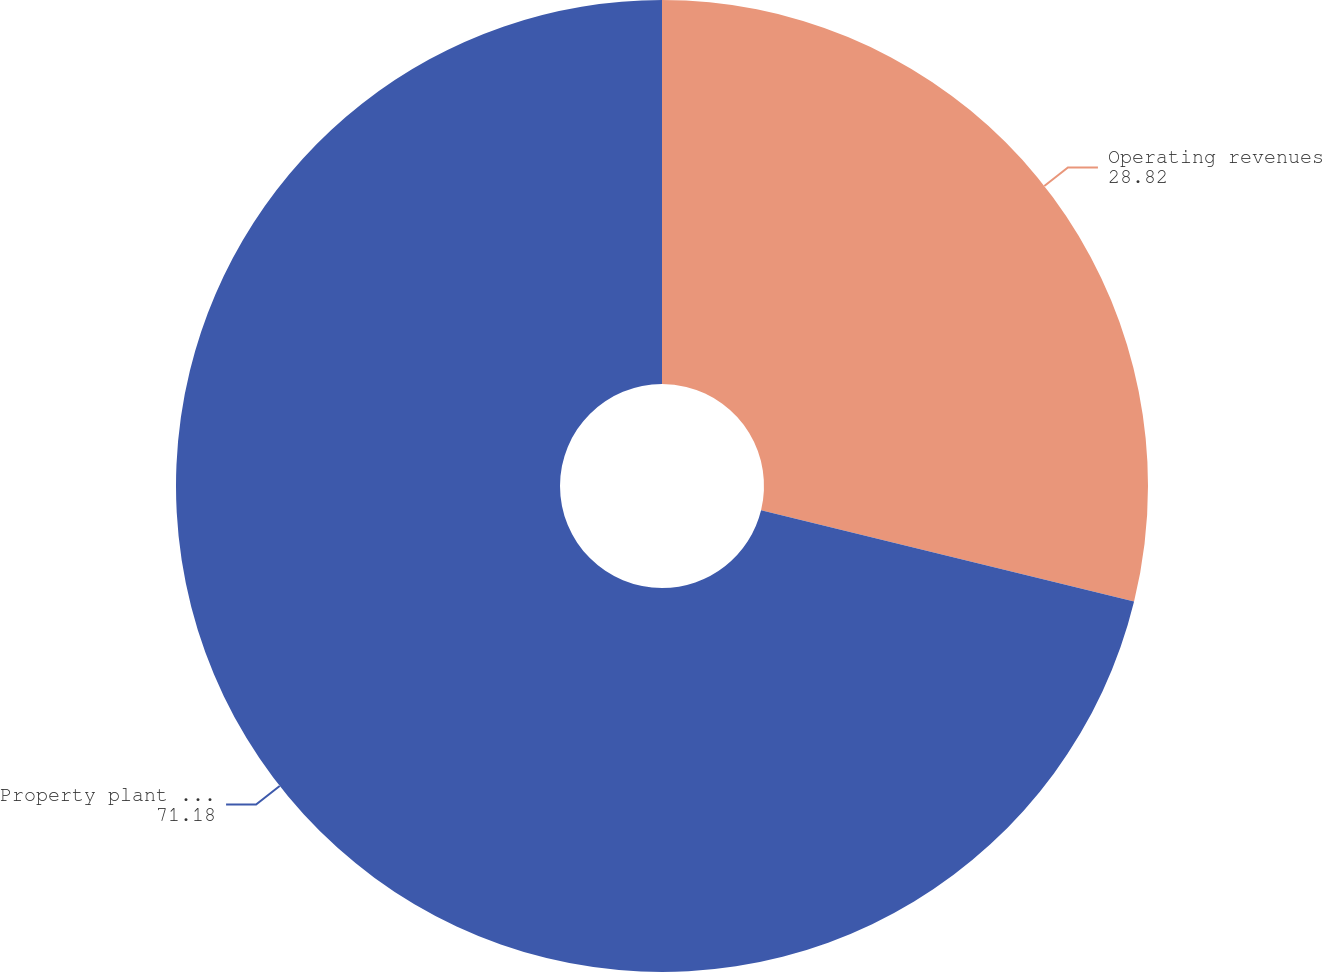Convert chart. <chart><loc_0><loc_0><loc_500><loc_500><pie_chart><fcel>Operating revenues<fcel>Property plant and equipment<nl><fcel>28.82%<fcel>71.18%<nl></chart> 